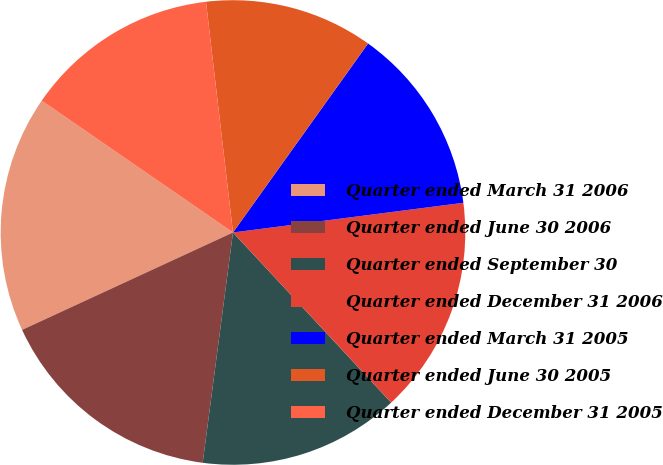Convert chart to OTSL. <chart><loc_0><loc_0><loc_500><loc_500><pie_chart><fcel>Quarter ended March 31 2006<fcel>Quarter ended June 30 2006<fcel>Quarter ended September 30<fcel>Quarter ended December 31 2006<fcel>Quarter ended March 31 2005<fcel>Quarter ended June 30 2005<fcel>Quarter ended December 31 2005<nl><fcel>16.49%<fcel>16.03%<fcel>14.0%<fcel>15.12%<fcel>13.08%<fcel>11.73%<fcel>13.54%<nl></chart> 